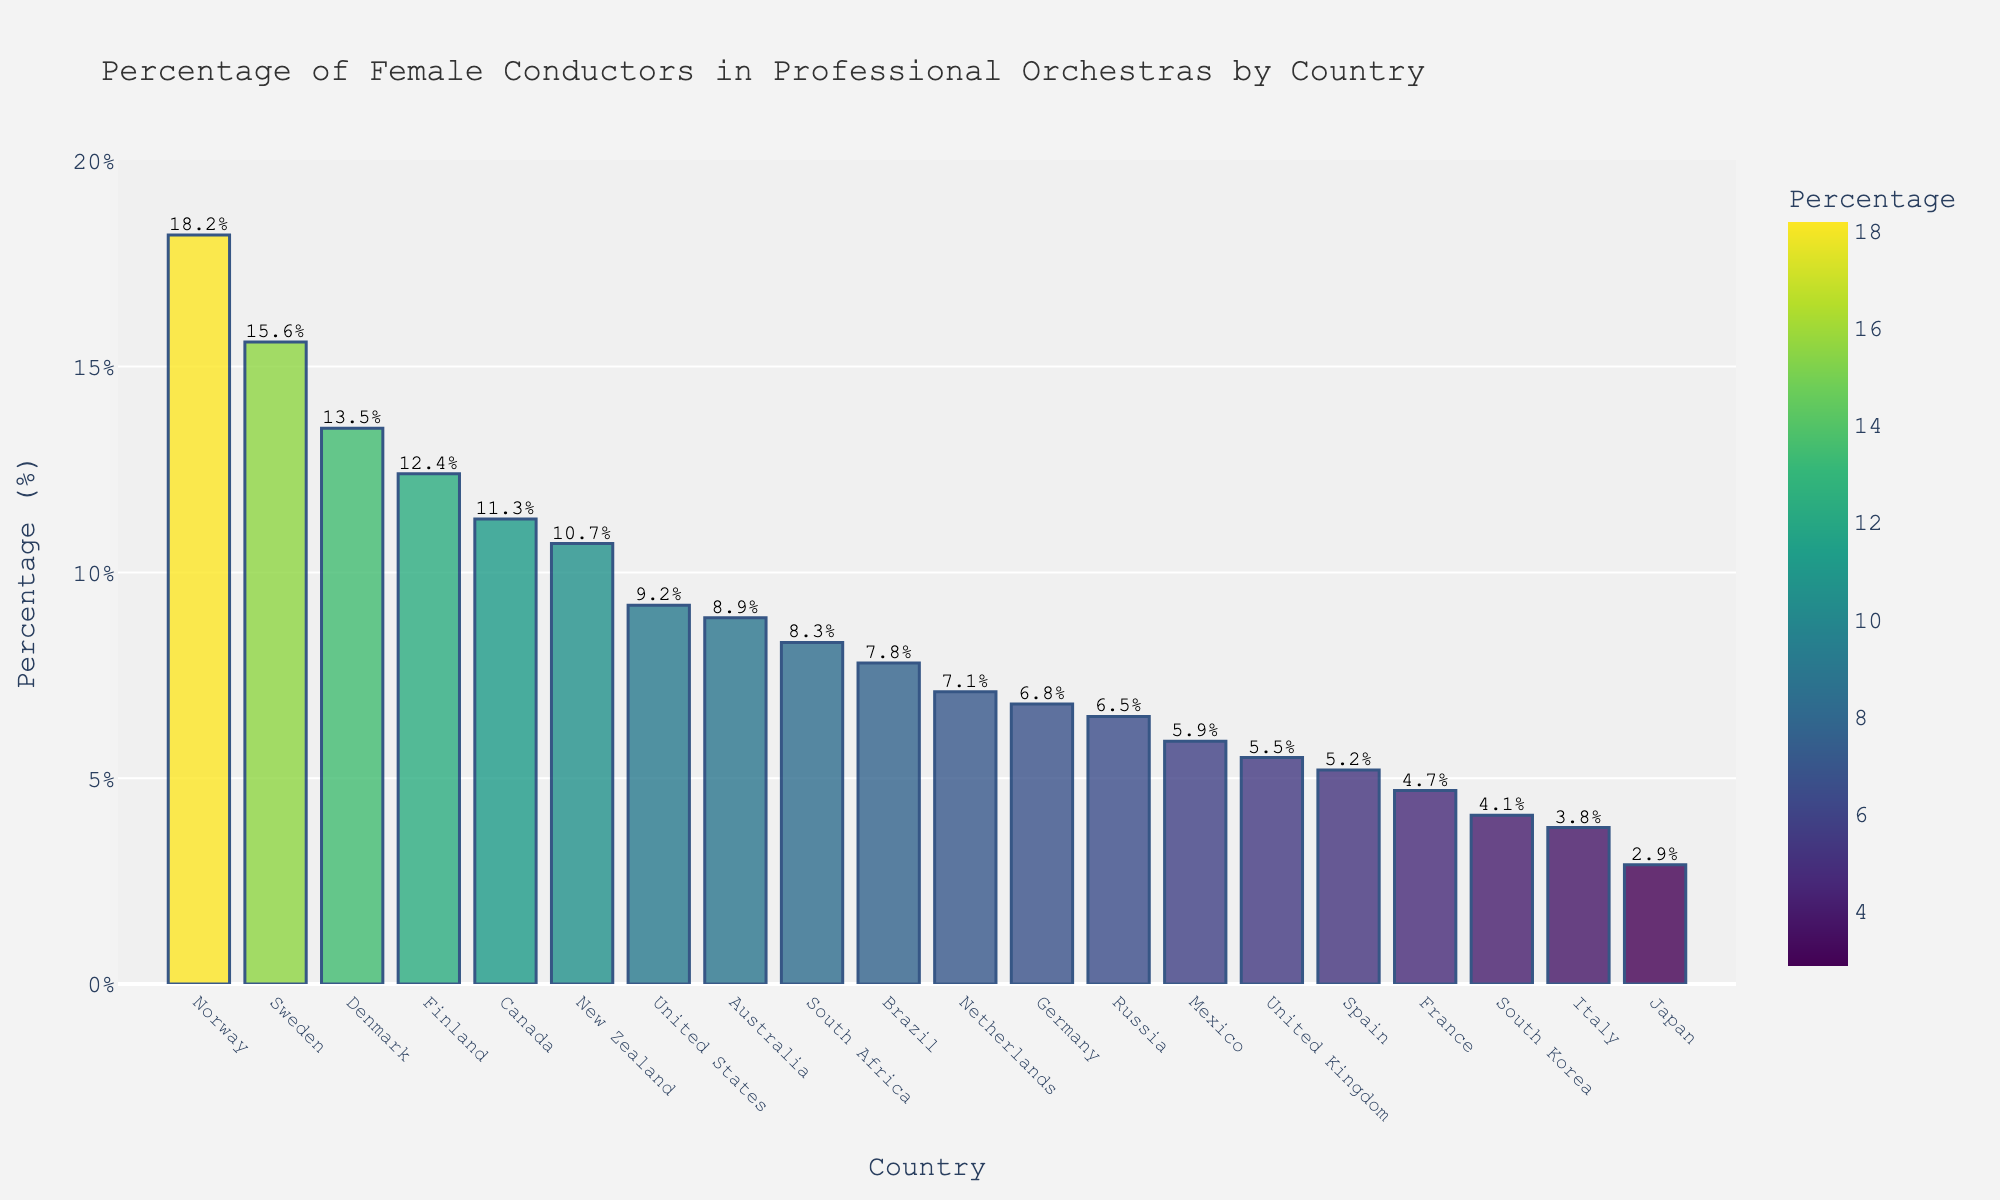Which country has the highest percentage of female conductors in professional orchestras? Look at the bar with the greatest height; in this case, it represents Norway.
Answer: Norway Which country has the lowest percentage of female conductors? Look for the shortest bar in the chart, which corresponds to Japan.
Answer: Japan How does the percentage of female conductors in Sweden compare to that in Canada? Check the heights of the bars corresponding to Sweden and Canada. Sweden has a higher percentage.
Answer: Sweden has a higher percentage What is the average percentage of female conductors in the top three countries? Identify the top three countries (Norway, Sweden, and Denmark) and calculate the mean of their percentages: (18.2 + 15.6 + 13.5) / 3 = 47.3 / 3.
Answer: 15.8% How many countries have a higher percentage than the global average of 9.2%? Identify and count the countries whose bars exceed the 9.2% mark: Canada, Sweden, Norway, Finland, New Zealand, and Denmark.
Answer: 6 countries What percentage difference is there between the countries with the highest and lowest female conductors? Subtract the lowest percentage (Japan, 2.9%) from the highest (Norway, 18.2%): 18.2% - 2.9%.
Answer: 15.3% Are there more countries with a percentage above 10% or below 10%? Count the countries with percentages above 10% (5 countries) and below 10% (14 countries). Compare these counts.
Answer: More countries have a percentage below 10% Which country ranks just above Spain in terms of female conductors' percentage? Find Spain on the chart and identify the country immediately above it in terms of percentage, which is Germany.
Answer: Germany What is the combined percentage of female conductors for France and Italy? Sum the percentages of France (4.7%) and Italy (3.8%): 4.7% + 3.8%.
Answer: 8.5% How does the color of the bar for Norway differ from that of Japan? Notice that the bar for Norway is in a darker shade due to its higher percentage compared to the lighter shade for Japan.
Answer: Norway's bar is darker 